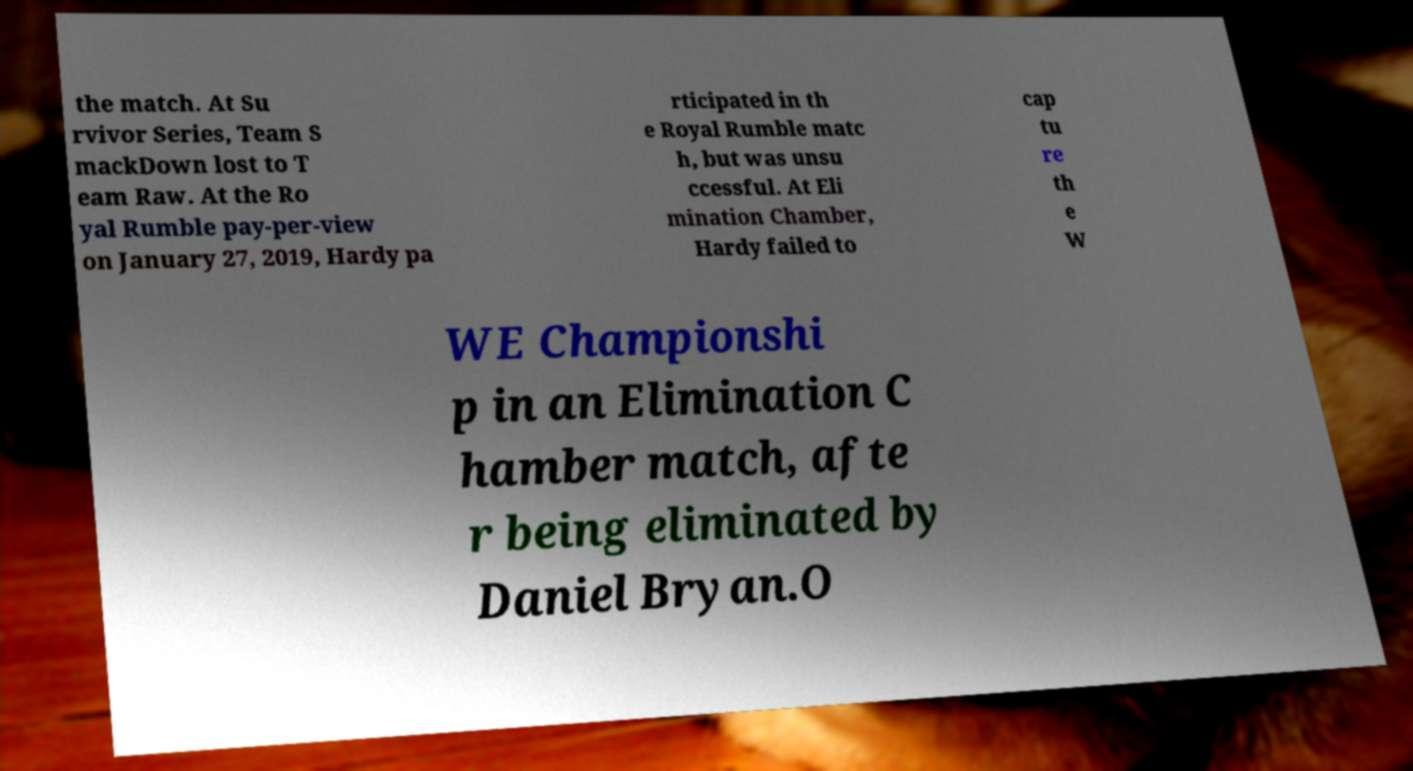Could you extract and type out the text from this image? the match. At Su rvivor Series, Team S mackDown lost to T eam Raw. At the Ro yal Rumble pay-per-view on January 27, 2019, Hardy pa rticipated in th e Royal Rumble matc h, but was unsu ccessful. At Eli mination Chamber, Hardy failed to cap tu re th e W WE Championshi p in an Elimination C hamber match, afte r being eliminated by Daniel Bryan.O 